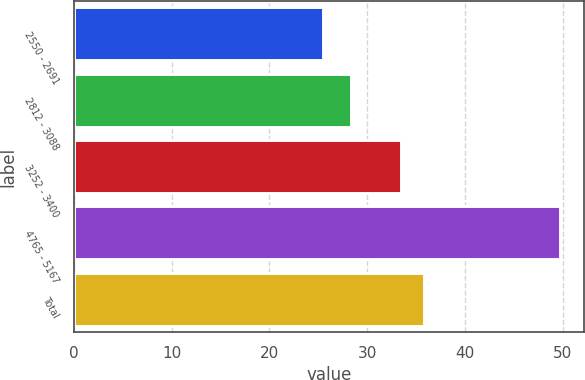<chart> <loc_0><loc_0><loc_500><loc_500><bar_chart><fcel>2550 - 2691<fcel>2812 - 3088<fcel>3252 - 3400<fcel>4765 - 5167<fcel>Total<nl><fcel>25.53<fcel>28.39<fcel>33.44<fcel>49.75<fcel>35.86<nl></chart> 